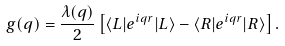<formula> <loc_0><loc_0><loc_500><loc_500>g ( { q } ) = \frac { \lambda ( { q } ) } { 2 } \left [ \langle L | e ^ { i { q r } } | L \rangle - \langle R | e ^ { i { q r } } | R \rangle \right ] .</formula> 